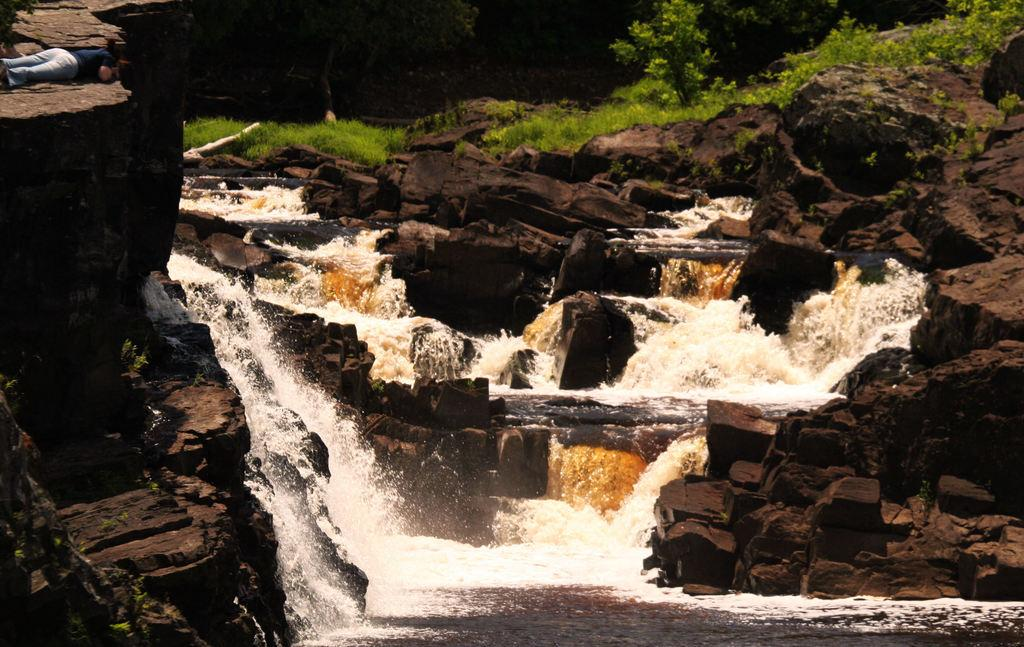What natural feature is the main subject of the image? There is a waterfall in the image. What else can be seen in the image besides the waterfall? There are rocks, a person lying on a rock, plants, and trees in the background of the image. Can you describe the person's position in the image? The person is lying on a rock in the image. What type of vegetation is visible in the background of the image? There are plants and trees in the background of the image. What type of tramp can be seen jumping over the waterfall in the image? There is no tramp present in the image, and no one is jumping over the waterfall. Can you describe the fight between the cats in the image? There are no cats present in the image, and therefore no fight can be observed. 